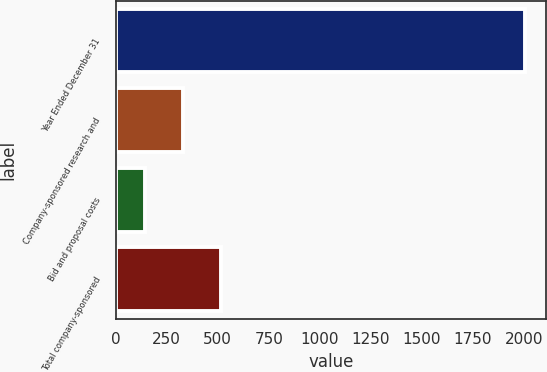<chart> <loc_0><loc_0><loc_500><loc_500><bar_chart><fcel>Year Ended December 31<fcel>Company-sponsored research and<fcel>Bid and proposal costs<fcel>Total company-sponsored<nl><fcel>2007<fcel>329.4<fcel>143<fcel>515.8<nl></chart> 